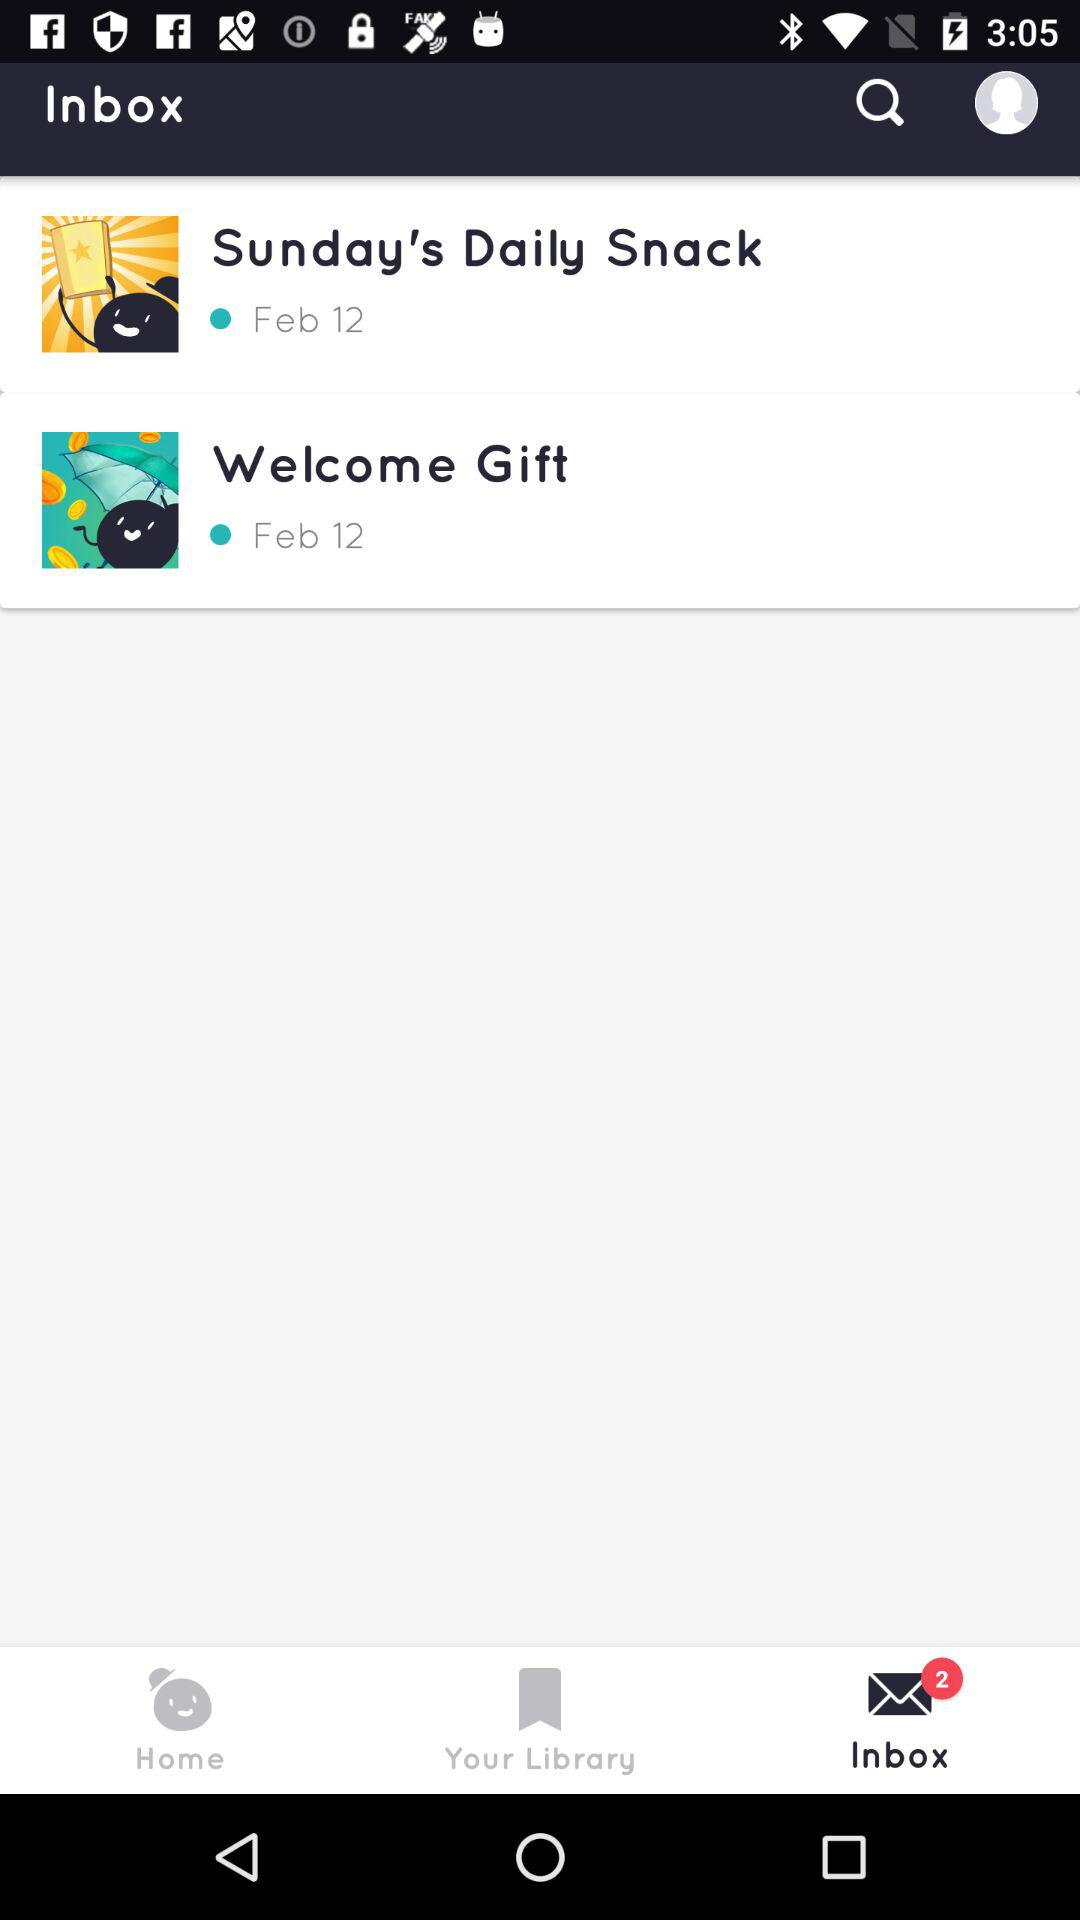How many unread items are there?
Answer the question using a single word or phrase. 2 